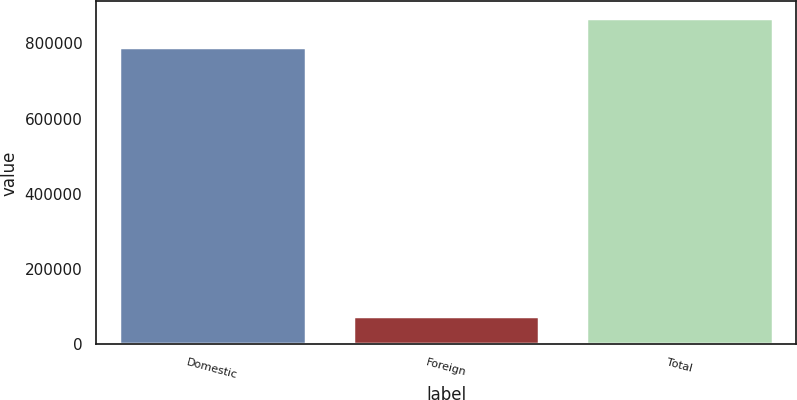Convert chart. <chart><loc_0><loc_0><loc_500><loc_500><bar_chart><fcel>Domestic<fcel>Foreign<fcel>Total<nl><fcel>788878<fcel>74961<fcel>867766<nl></chart> 